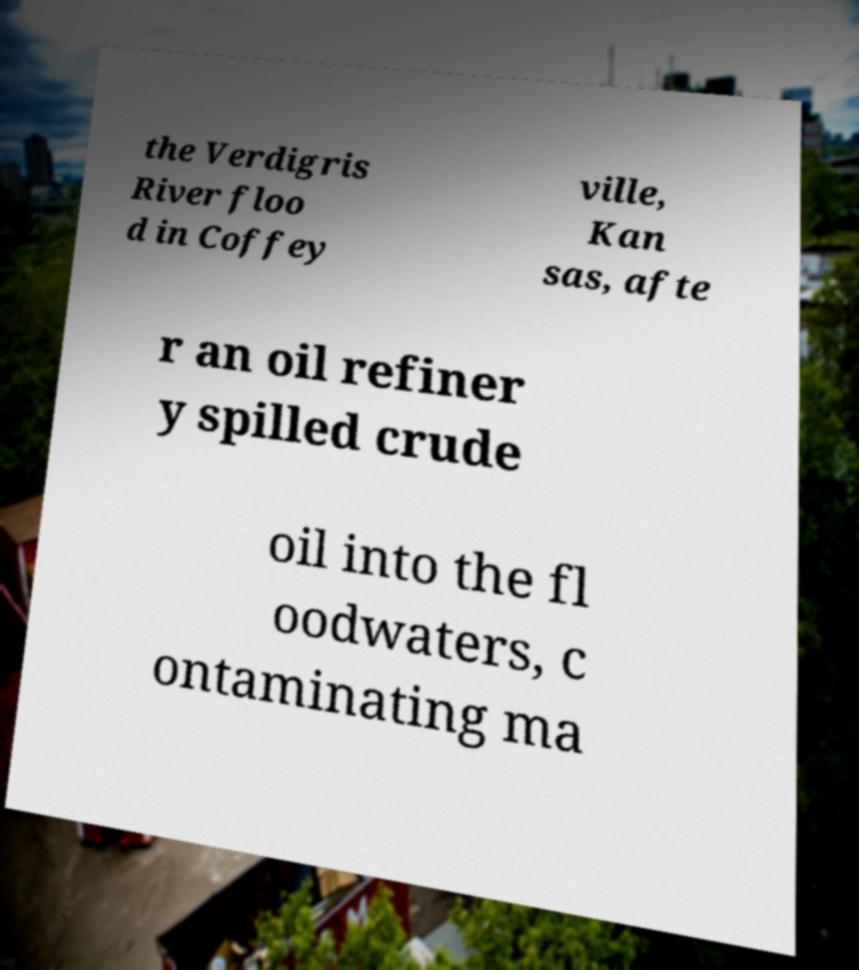Please identify and transcribe the text found in this image. the Verdigris River floo d in Coffey ville, Kan sas, afte r an oil refiner y spilled crude oil into the fl oodwaters, c ontaminating ma 